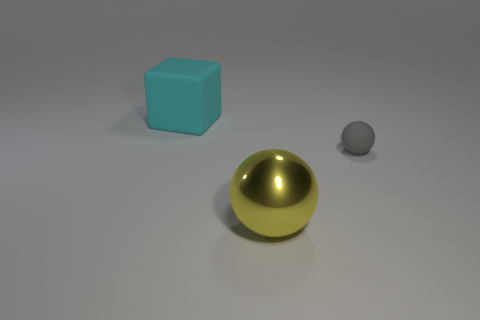Does the gray matte thing have the same size as the yellow metallic object?
Keep it short and to the point. No. Is the number of cyan rubber cubes greater than the number of small purple metal blocks?
Offer a very short reply. Yes. What number of things are either brown matte blocks or matte blocks?
Your answer should be compact. 1. There is a large object that is in front of the matte sphere; is it the same shape as the small thing?
Make the answer very short. Yes. The ball that is to the left of the matte object on the right side of the big sphere is what color?
Ensure brevity in your answer.  Yellow. Is the number of tiny gray rubber spheres less than the number of spheres?
Your answer should be compact. Yes. Is there a small gray ball made of the same material as the small object?
Your response must be concise. No. There is a yellow object; is it the same shape as the object behind the gray matte thing?
Offer a very short reply. No. Are there any large objects behind the yellow metallic thing?
Your response must be concise. Yes. How many large matte things have the same shape as the small gray thing?
Make the answer very short. 0. 